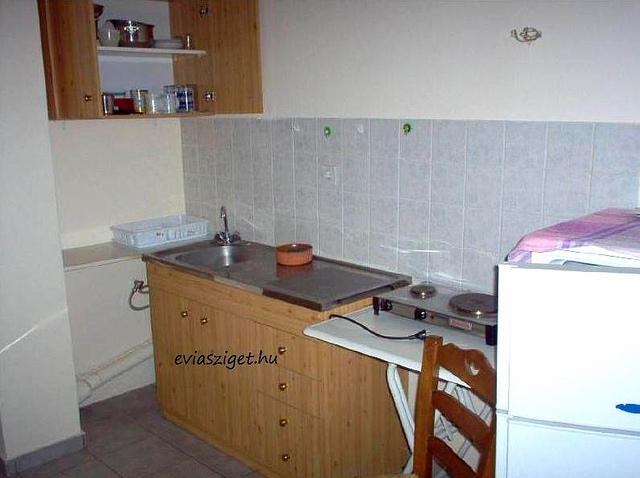Is there a microwave?
Write a very short answer. No. Is the refrigerator in this room a mini fridge?
Quick response, please. Yes. Is this a large kitchen?
Keep it brief. No. In the chair in place?
Be succinct. No. 